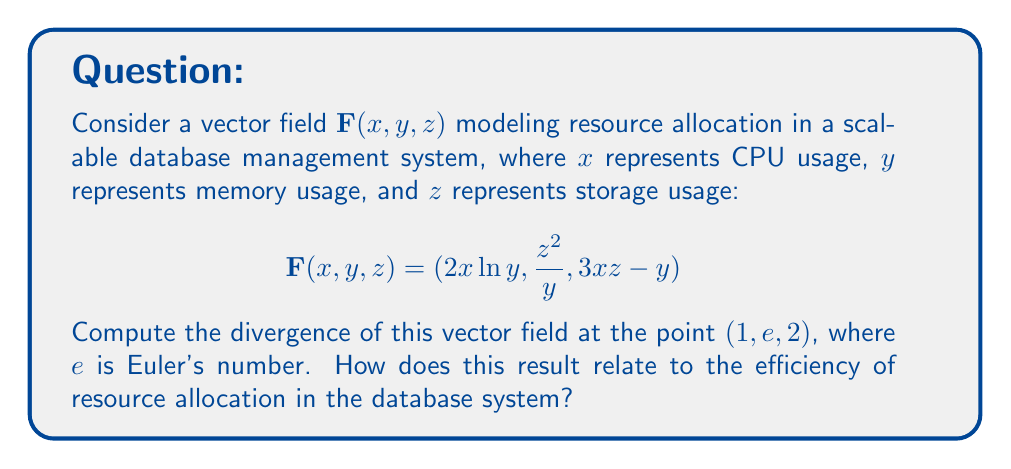Help me with this question. To compute the divergence of the vector field, we need to follow these steps:

1) The divergence of a vector field $\mathbf{F}(x, y, z) = (F_1, F_2, F_3)$ is given by:

   $$\text{div}\mathbf{F} = \nabla \cdot \mathbf{F} = \frac{\partial F_1}{\partial x} + \frac{\partial F_2}{\partial y} + \frac{\partial F_3}{\partial z}$$

2) Let's compute each partial derivative:

   $\frac{\partial F_1}{\partial x} = \frac{\partial}{\partial x}(2x\ln y) = 2\ln y$

   $\frac{\partial F_2}{\partial y} = \frac{\partial}{\partial y}(\frac{z^2}{y}) = -\frac{z^2}{y^2}$

   $\frac{\partial F_3}{\partial z} = \frac{\partial}{\partial z}(3xz - y) = 3x$

3) Now, we sum these partial derivatives:

   $$\text{div}\mathbf{F} = 2\ln y - \frac{z^2}{y^2} + 3x$$

4) Evaluate this at the point $(1, e, 2)$:

   $$\text{div}\mathbf{F}(1, e, 2) = 2\ln e - \frac{2^2}{e^2} + 3(1) = 2 - \frac{4}{e^2} + 3 = 5 - \frac{4}{e^2}$$

The divergence at this point represents the net outflow of resources per unit volume. A positive divergence indicates that the system is allocating more resources than it's reclaiming, which could lead to resource depletion if not managed properly. The specific value $5 - \frac{4}{e^2}$ (approximately 4.46) suggests a significant outflow, indicating that the database system might be operating at high capacity or potentially over-allocating resources at this particular usage state.
Answer: $5 - \frac{4}{e^2}$ 